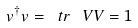Convert formula to latex. <formula><loc_0><loc_0><loc_500><loc_500>v ^ { \dagger } v = \ t r \, \ V V = 1</formula> 